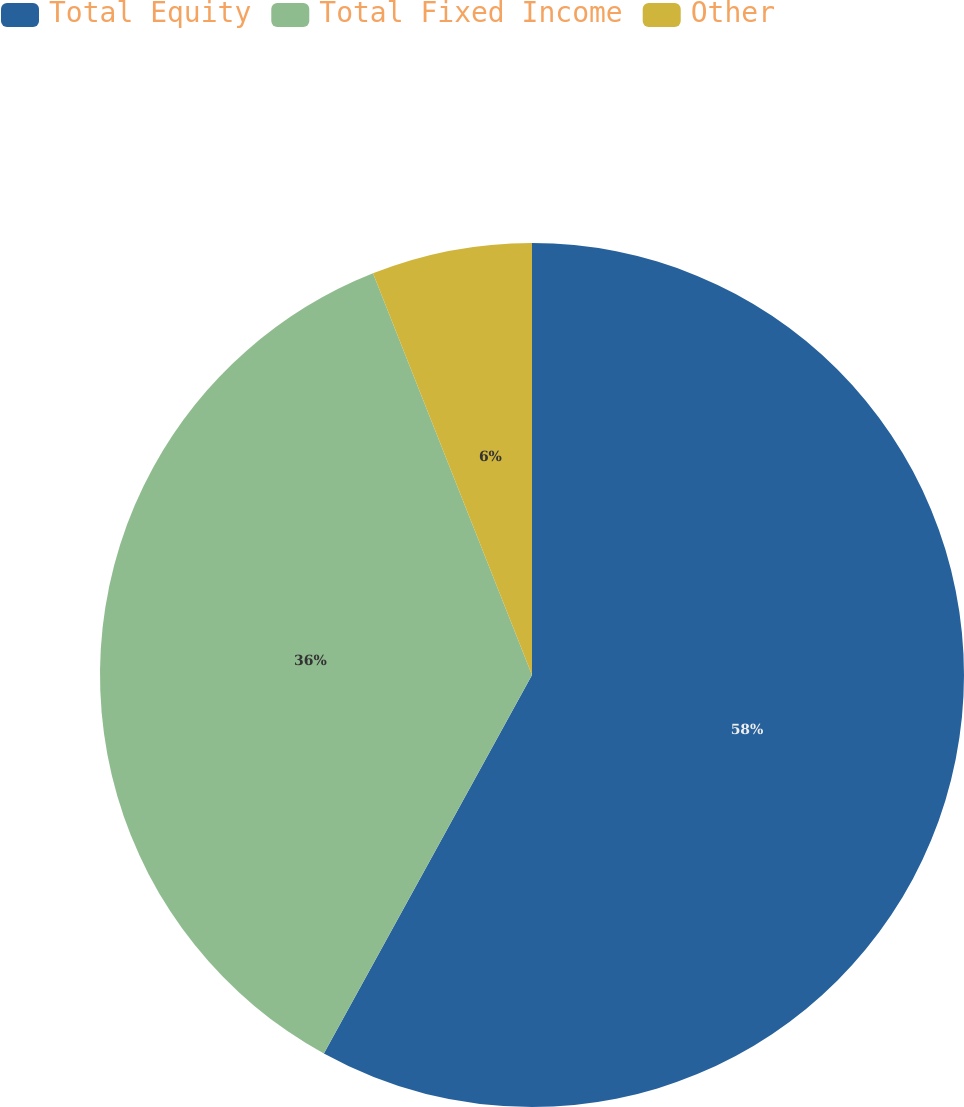Convert chart to OTSL. <chart><loc_0><loc_0><loc_500><loc_500><pie_chart><fcel>Total Equity<fcel>Total Fixed Income<fcel>Other<nl><fcel>58.0%<fcel>36.0%<fcel>6.0%<nl></chart> 